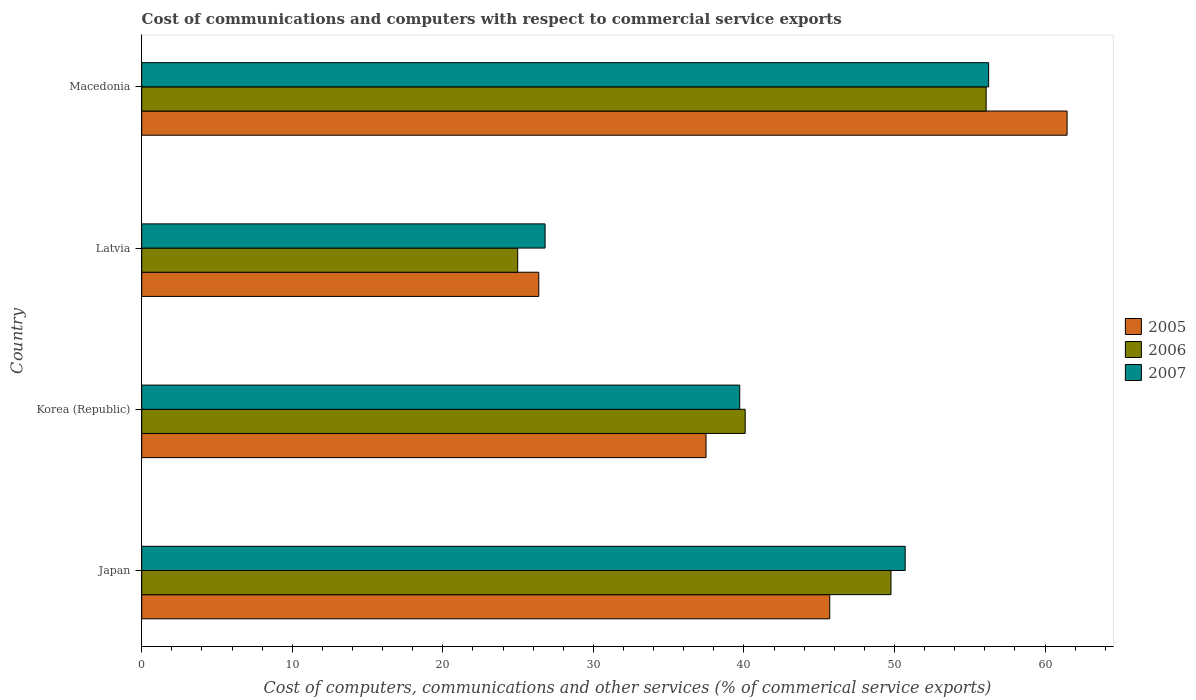Are the number of bars on each tick of the Y-axis equal?
Your answer should be compact. Yes. In how many cases, is the number of bars for a given country not equal to the number of legend labels?
Keep it short and to the point. 0. What is the cost of communications and computers in 2007 in Macedonia?
Your answer should be very brief. 56.25. Across all countries, what is the maximum cost of communications and computers in 2006?
Offer a terse response. 56.09. Across all countries, what is the minimum cost of communications and computers in 2005?
Offer a very short reply. 26.37. In which country was the cost of communications and computers in 2005 maximum?
Provide a succinct answer. Macedonia. In which country was the cost of communications and computers in 2006 minimum?
Give a very brief answer. Latvia. What is the total cost of communications and computers in 2005 in the graph?
Your answer should be very brief. 171.01. What is the difference between the cost of communications and computers in 2005 in Japan and that in Latvia?
Provide a short and direct response. 19.33. What is the difference between the cost of communications and computers in 2005 in Japan and the cost of communications and computers in 2007 in Macedonia?
Keep it short and to the point. -10.55. What is the average cost of communications and computers in 2007 per country?
Your answer should be very brief. 43.37. What is the difference between the cost of communications and computers in 2005 and cost of communications and computers in 2006 in Latvia?
Ensure brevity in your answer.  1.4. What is the ratio of the cost of communications and computers in 2007 in Latvia to that in Macedonia?
Provide a short and direct response. 0.48. What is the difference between the highest and the second highest cost of communications and computers in 2007?
Offer a terse response. 5.54. What is the difference between the highest and the lowest cost of communications and computers in 2005?
Give a very brief answer. 35.09. Is the sum of the cost of communications and computers in 2005 in Japan and Latvia greater than the maximum cost of communications and computers in 2006 across all countries?
Give a very brief answer. Yes. What does the 3rd bar from the top in Latvia represents?
Offer a terse response. 2005. What is the difference between two consecutive major ticks on the X-axis?
Ensure brevity in your answer.  10. Are the values on the major ticks of X-axis written in scientific E-notation?
Make the answer very short. No. Does the graph contain grids?
Your answer should be compact. No. Where does the legend appear in the graph?
Make the answer very short. Center right. What is the title of the graph?
Ensure brevity in your answer.  Cost of communications and computers with respect to commercial service exports. Does "2014" appear as one of the legend labels in the graph?
Provide a short and direct response. No. What is the label or title of the X-axis?
Provide a short and direct response. Cost of computers, communications and other services (% of commerical service exports). What is the Cost of computers, communications and other services (% of commerical service exports) of 2005 in Japan?
Give a very brief answer. 45.7. What is the Cost of computers, communications and other services (% of commerical service exports) of 2006 in Japan?
Keep it short and to the point. 49.77. What is the Cost of computers, communications and other services (% of commerical service exports) in 2007 in Japan?
Your response must be concise. 50.71. What is the Cost of computers, communications and other services (% of commerical service exports) of 2005 in Korea (Republic)?
Offer a terse response. 37.48. What is the Cost of computers, communications and other services (% of commerical service exports) in 2006 in Korea (Republic)?
Give a very brief answer. 40.08. What is the Cost of computers, communications and other services (% of commerical service exports) of 2007 in Korea (Republic)?
Offer a terse response. 39.72. What is the Cost of computers, communications and other services (% of commerical service exports) of 2005 in Latvia?
Your answer should be compact. 26.37. What is the Cost of computers, communications and other services (% of commerical service exports) of 2006 in Latvia?
Keep it short and to the point. 24.97. What is the Cost of computers, communications and other services (% of commerical service exports) of 2007 in Latvia?
Your answer should be very brief. 26.79. What is the Cost of computers, communications and other services (% of commerical service exports) in 2005 in Macedonia?
Your response must be concise. 61.46. What is the Cost of computers, communications and other services (% of commerical service exports) of 2006 in Macedonia?
Your answer should be compact. 56.09. What is the Cost of computers, communications and other services (% of commerical service exports) in 2007 in Macedonia?
Your answer should be compact. 56.25. Across all countries, what is the maximum Cost of computers, communications and other services (% of commerical service exports) of 2005?
Provide a short and direct response. 61.46. Across all countries, what is the maximum Cost of computers, communications and other services (% of commerical service exports) in 2006?
Ensure brevity in your answer.  56.09. Across all countries, what is the maximum Cost of computers, communications and other services (% of commerical service exports) in 2007?
Give a very brief answer. 56.25. Across all countries, what is the minimum Cost of computers, communications and other services (% of commerical service exports) in 2005?
Provide a succinct answer. 26.37. Across all countries, what is the minimum Cost of computers, communications and other services (% of commerical service exports) of 2006?
Make the answer very short. 24.97. Across all countries, what is the minimum Cost of computers, communications and other services (% of commerical service exports) of 2007?
Make the answer very short. 26.79. What is the total Cost of computers, communications and other services (% of commerical service exports) in 2005 in the graph?
Give a very brief answer. 171.01. What is the total Cost of computers, communications and other services (% of commerical service exports) of 2006 in the graph?
Your response must be concise. 170.91. What is the total Cost of computers, communications and other services (% of commerical service exports) in 2007 in the graph?
Ensure brevity in your answer.  173.47. What is the difference between the Cost of computers, communications and other services (% of commerical service exports) in 2005 in Japan and that in Korea (Republic)?
Your response must be concise. 8.22. What is the difference between the Cost of computers, communications and other services (% of commerical service exports) of 2006 in Japan and that in Korea (Republic)?
Keep it short and to the point. 9.68. What is the difference between the Cost of computers, communications and other services (% of commerical service exports) of 2007 in Japan and that in Korea (Republic)?
Your answer should be compact. 10.99. What is the difference between the Cost of computers, communications and other services (% of commerical service exports) in 2005 in Japan and that in Latvia?
Give a very brief answer. 19.33. What is the difference between the Cost of computers, communications and other services (% of commerical service exports) of 2006 in Japan and that in Latvia?
Give a very brief answer. 24.79. What is the difference between the Cost of computers, communications and other services (% of commerical service exports) in 2007 in Japan and that in Latvia?
Offer a very short reply. 23.92. What is the difference between the Cost of computers, communications and other services (% of commerical service exports) in 2005 in Japan and that in Macedonia?
Offer a terse response. -15.77. What is the difference between the Cost of computers, communications and other services (% of commerical service exports) of 2006 in Japan and that in Macedonia?
Keep it short and to the point. -6.32. What is the difference between the Cost of computers, communications and other services (% of commerical service exports) of 2007 in Japan and that in Macedonia?
Your response must be concise. -5.54. What is the difference between the Cost of computers, communications and other services (% of commerical service exports) of 2005 in Korea (Republic) and that in Latvia?
Your answer should be very brief. 11.11. What is the difference between the Cost of computers, communications and other services (% of commerical service exports) in 2006 in Korea (Republic) and that in Latvia?
Ensure brevity in your answer.  15.11. What is the difference between the Cost of computers, communications and other services (% of commerical service exports) of 2007 in Korea (Republic) and that in Latvia?
Your answer should be compact. 12.93. What is the difference between the Cost of computers, communications and other services (% of commerical service exports) of 2005 in Korea (Republic) and that in Macedonia?
Your response must be concise. -23.98. What is the difference between the Cost of computers, communications and other services (% of commerical service exports) of 2006 in Korea (Republic) and that in Macedonia?
Keep it short and to the point. -16. What is the difference between the Cost of computers, communications and other services (% of commerical service exports) of 2007 in Korea (Republic) and that in Macedonia?
Ensure brevity in your answer.  -16.53. What is the difference between the Cost of computers, communications and other services (% of commerical service exports) in 2005 in Latvia and that in Macedonia?
Offer a terse response. -35.09. What is the difference between the Cost of computers, communications and other services (% of commerical service exports) in 2006 in Latvia and that in Macedonia?
Give a very brief answer. -31.11. What is the difference between the Cost of computers, communications and other services (% of commerical service exports) in 2007 in Latvia and that in Macedonia?
Give a very brief answer. -29.46. What is the difference between the Cost of computers, communications and other services (% of commerical service exports) in 2005 in Japan and the Cost of computers, communications and other services (% of commerical service exports) in 2006 in Korea (Republic)?
Give a very brief answer. 5.62. What is the difference between the Cost of computers, communications and other services (% of commerical service exports) of 2005 in Japan and the Cost of computers, communications and other services (% of commerical service exports) of 2007 in Korea (Republic)?
Make the answer very short. 5.98. What is the difference between the Cost of computers, communications and other services (% of commerical service exports) in 2006 in Japan and the Cost of computers, communications and other services (% of commerical service exports) in 2007 in Korea (Republic)?
Your response must be concise. 10.05. What is the difference between the Cost of computers, communications and other services (% of commerical service exports) in 2005 in Japan and the Cost of computers, communications and other services (% of commerical service exports) in 2006 in Latvia?
Your response must be concise. 20.72. What is the difference between the Cost of computers, communications and other services (% of commerical service exports) of 2005 in Japan and the Cost of computers, communications and other services (% of commerical service exports) of 2007 in Latvia?
Your answer should be compact. 18.91. What is the difference between the Cost of computers, communications and other services (% of commerical service exports) in 2006 in Japan and the Cost of computers, communications and other services (% of commerical service exports) in 2007 in Latvia?
Your response must be concise. 22.97. What is the difference between the Cost of computers, communications and other services (% of commerical service exports) in 2005 in Japan and the Cost of computers, communications and other services (% of commerical service exports) in 2006 in Macedonia?
Make the answer very short. -10.39. What is the difference between the Cost of computers, communications and other services (% of commerical service exports) in 2005 in Japan and the Cost of computers, communications and other services (% of commerical service exports) in 2007 in Macedonia?
Keep it short and to the point. -10.55. What is the difference between the Cost of computers, communications and other services (% of commerical service exports) of 2006 in Japan and the Cost of computers, communications and other services (% of commerical service exports) of 2007 in Macedonia?
Ensure brevity in your answer.  -6.49. What is the difference between the Cost of computers, communications and other services (% of commerical service exports) in 2005 in Korea (Republic) and the Cost of computers, communications and other services (% of commerical service exports) in 2006 in Latvia?
Provide a succinct answer. 12.51. What is the difference between the Cost of computers, communications and other services (% of commerical service exports) of 2005 in Korea (Republic) and the Cost of computers, communications and other services (% of commerical service exports) of 2007 in Latvia?
Keep it short and to the point. 10.69. What is the difference between the Cost of computers, communications and other services (% of commerical service exports) of 2006 in Korea (Republic) and the Cost of computers, communications and other services (% of commerical service exports) of 2007 in Latvia?
Your answer should be very brief. 13.29. What is the difference between the Cost of computers, communications and other services (% of commerical service exports) of 2005 in Korea (Republic) and the Cost of computers, communications and other services (% of commerical service exports) of 2006 in Macedonia?
Your answer should be very brief. -18.6. What is the difference between the Cost of computers, communications and other services (% of commerical service exports) in 2005 in Korea (Republic) and the Cost of computers, communications and other services (% of commerical service exports) in 2007 in Macedonia?
Your answer should be compact. -18.77. What is the difference between the Cost of computers, communications and other services (% of commerical service exports) of 2006 in Korea (Republic) and the Cost of computers, communications and other services (% of commerical service exports) of 2007 in Macedonia?
Keep it short and to the point. -16.17. What is the difference between the Cost of computers, communications and other services (% of commerical service exports) of 2005 in Latvia and the Cost of computers, communications and other services (% of commerical service exports) of 2006 in Macedonia?
Keep it short and to the point. -29.71. What is the difference between the Cost of computers, communications and other services (% of commerical service exports) in 2005 in Latvia and the Cost of computers, communications and other services (% of commerical service exports) in 2007 in Macedonia?
Ensure brevity in your answer.  -29.88. What is the difference between the Cost of computers, communications and other services (% of commerical service exports) in 2006 in Latvia and the Cost of computers, communications and other services (% of commerical service exports) in 2007 in Macedonia?
Your response must be concise. -31.28. What is the average Cost of computers, communications and other services (% of commerical service exports) of 2005 per country?
Your response must be concise. 42.75. What is the average Cost of computers, communications and other services (% of commerical service exports) of 2006 per country?
Ensure brevity in your answer.  42.73. What is the average Cost of computers, communications and other services (% of commerical service exports) in 2007 per country?
Give a very brief answer. 43.37. What is the difference between the Cost of computers, communications and other services (% of commerical service exports) in 2005 and Cost of computers, communications and other services (% of commerical service exports) in 2006 in Japan?
Keep it short and to the point. -4.07. What is the difference between the Cost of computers, communications and other services (% of commerical service exports) in 2005 and Cost of computers, communications and other services (% of commerical service exports) in 2007 in Japan?
Your answer should be very brief. -5.01. What is the difference between the Cost of computers, communications and other services (% of commerical service exports) of 2006 and Cost of computers, communications and other services (% of commerical service exports) of 2007 in Japan?
Keep it short and to the point. -0.94. What is the difference between the Cost of computers, communications and other services (% of commerical service exports) in 2005 and Cost of computers, communications and other services (% of commerical service exports) in 2006 in Korea (Republic)?
Offer a terse response. -2.6. What is the difference between the Cost of computers, communications and other services (% of commerical service exports) of 2005 and Cost of computers, communications and other services (% of commerical service exports) of 2007 in Korea (Republic)?
Your answer should be compact. -2.24. What is the difference between the Cost of computers, communications and other services (% of commerical service exports) of 2006 and Cost of computers, communications and other services (% of commerical service exports) of 2007 in Korea (Republic)?
Ensure brevity in your answer.  0.36. What is the difference between the Cost of computers, communications and other services (% of commerical service exports) of 2005 and Cost of computers, communications and other services (% of commerical service exports) of 2006 in Latvia?
Your answer should be very brief. 1.4. What is the difference between the Cost of computers, communications and other services (% of commerical service exports) of 2005 and Cost of computers, communications and other services (% of commerical service exports) of 2007 in Latvia?
Your response must be concise. -0.42. What is the difference between the Cost of computers, communications and other services (% of commerical service exports) in 2006 and Cost of computers, communications and other services (% of commerical service exports) in 2007 in Latvia?
Ensure brevity in your answer.  -1.82. What is the difference between the Cost of computers, communications and other services (% of commerical service exports) in 2005 and Cost of computers, communications and other services (% of commerical service exports) in 2006 in Macedonia?
Ensure brevity in your answer.  5.38. What is the difference between the Cost of computers, communications and other services (% of commerical service exports) of 2005 and Cost of computers, communications and other services (% of commerical service exports) of 2007 in Macedonia?
Ensure brevity in your answer.  5.21. What is the difference between the Cost of computers, communications and other services (% of commerical service exports) of 2006 and Cost of computers, communications and other services (% of commerical service exports) of 2007 in Macedonia?
Make the answer very short. -0.17. What is the ratio of the Cost of computers, communications and other services (% of commerical service exports) of 2005 in Japan to that in Korea (Republic)?
Your response must be concise. 1.22. What is the ratio of the Cost of computers, communications and other services (% of commerical service exports) of 2006 in Japan to that in Korea (Republic)?
Keep it short and to the point. 1.24. What is the ratio of the Cost of computers, communications and other services (% of commerical service exports) of 2007 in Japan to that in Korea (Republic)?
Offer a terse response. 1.28. What is the ratio of the Cost of computers, communications and other services (% of commerical service exports) in 2005 in Japan to that in Latvia?
Offer a very short reply. 1.73. What is the ratio of the Cost of computers, communications and other services (% of commerical service exports) in 2006 in Japan to that in Latvia?
Offer a very short reply. 1.99. What is the ratio of the Cost of computers, communications and other services (% of commerical service exports) in 2007 in Japan to that in Latvia?
Your response must be concise. 1.89. What is the ratio of the Cost of computers, communications and other services (% of commerical service exports) of 2005 in Japan to that in Macedonia?
Offer a very short reply. 0.74. What is the ratio of the Cost of computers, communications and other services (% of commerical service exports) in 2006 in Japan to that in Macedonia?
Make the answer very short. 0.89. What is the ratio of the Cost of computers, communications and other services (% of commerical service exports) in 2007 in Japan to that in Macedonia?
Make the answer very short. 0.9. What is the ratio of the Cost of computers, communications and other services (% of commerical service exports) of 2005 in Korea (Republic) to that in Latvia?
Give a very brief answer. 1.42. What is the ratio of the Cost of computers, communications and other services (% of commerical service exports) of 2006 in Korea (Republic) to that in Latvia?
Ensure brevity in your answer.  1.6. What is the ratio of the Cost of computers, communications and other services (% of commerical service exports) in 2007 in Korea (Republic) to that in Latvia?
Keep it short and to the point. 1.48. What is the ratio of the Cost of computers, communications and other services (% of commerical service exports) in 2005 in Korea (Republic) to that in Macedonia?
Your response must be concise. 0.61. What is the ratio of the Cost of computers, communications and other services (% of commerical service exports) in 2006 in Korea (Republic) to that in Macedonia?
Offer a very short reply. 0.71. What is the ratio of the Cost of computers, communications and other services (% of commerical service exports) of 2007 in Korea (Republic) to that in Macedonia?
Provide a short and direct response. 0.71. What is the ratio of the Cost of computers, communications and other services (% of commerical service exports) in 2005 in Latvia to that in Macedonia?
Provide a short and direct response. 0.43. What is the ratio of the Cost of computers, communications and other services (% of commerical service exports) in 2006 in Latvia to that in Macedonia?
Ensure brevity in your answer.  0.45. What is the ratio of the Cost of computers, communications and other services (% of commerical service exports) in 2007 in Latvia to that in Macedonia?
Offer a terse response. 0.48. What is the difference between the highest and the second highest Cost of computers, communications and other services (% of commerical service exports) in 2005?
Make the answer very short. 15.77. What is the difference between the highest and the second highest Cost of computers, communications and other services (% of commerical service exports) in 2006?
Give a very brief answer. 6.32. What is the difference between the highest and the second highest Cost of computers, communications and other services (% of commerical service exports) in 2007?
Your response must be concise. 5.54. What is the difference between the highest and the lowest Cost of computers, communications and other services (% of commerical service exports) in 2005?
Keep it short and to the point. 35.09. What is the difference between the highest and the lowest Cost of computers, communications and other services (% of commerical service exports) of 2006?
Keep it short and to the point. 31.11. What is the difference between the highest and the lowest Cost of computers, communications and other services (% of commerical service exports) of 2007?
Keep it short and to the point. 29.46. 